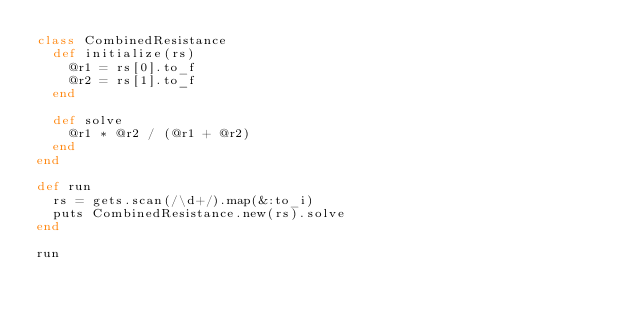Convert code to text. <code><loc_0><loc_0><loc_500><loc_500><_Ruby_>class CombinedResistance
  def initialize(rs)
    @r1 = rs[0].to_f
    @r2 = rs[1].to_f
  end

  def solve
    @r1 * @r2 / (@r1 + @r2)
  end
end

def run
  rs = gets.scan(/\d+/).map(&:to_i)
  puts CombinedResistance.new(rs).solve
end

run
</code> 